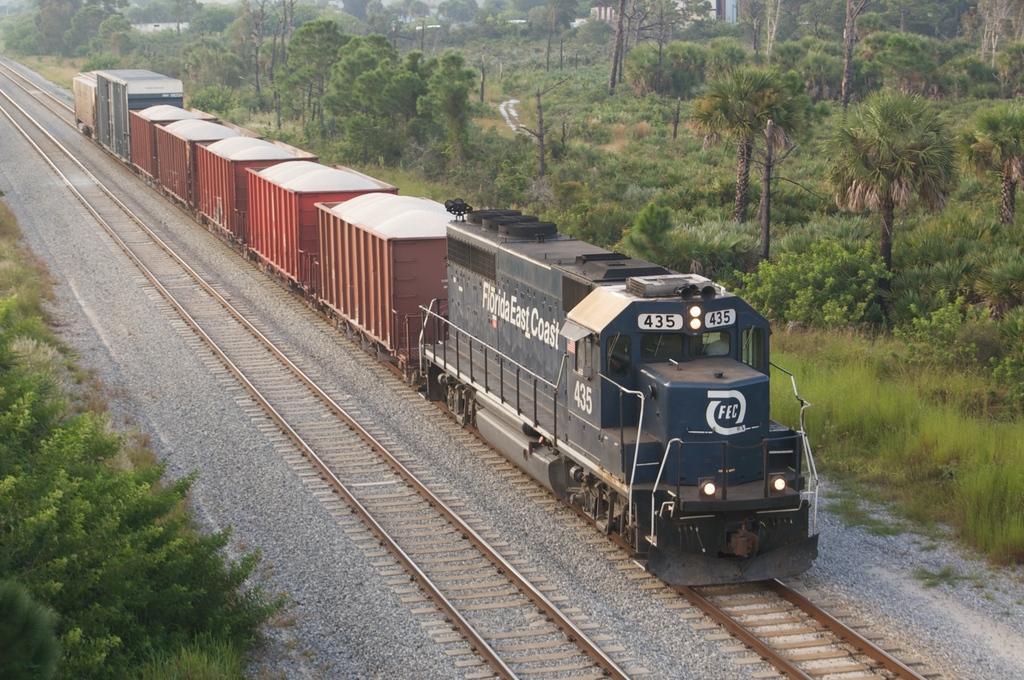Describe this image in one or two sentences. In this picture we can see a train, railway tracks, stones, plants and in the background we can see trees. 